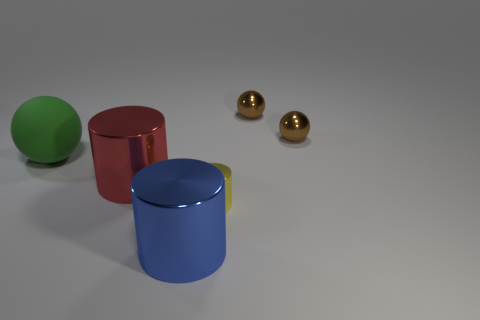What material is the sphere to the left of the big shiny thing that is in front of the metallic cylinder that is on the right side of the big blue metal object?
Your response must be concise. Rubber. Does the small metallic cylinder have the same color as the shiny cylinder that is left of the big blue metal cylinder?
Provide a succinct answer. No. How many things are either things right of the large matte sphere or things that are in front of the small yellow cylinder?
Offer a terse response. 5. What is the shape of the big shiny object in front of the tiny thing in front of the large ball?
Offer a terse response. Cylinder. Is there a blue cylinder that has the same material as the red object?
Offer a very short reply. Yes. There is another big thing that is the same shape as the blue object; what is its color?
Keep it short and to the point. Red. Is the number of tiny metallic balls that are on the left side of the large green matte sphere less than the number of big cylinders that are on the right side of the big blue cylinder?
Make the answer very short. No. How many other objects are there of the same shape as the large red object?
Provide a succinct answer. 2. Is the number of big shiny objects to the right of the yellow cylinder less than the number of big green rubber things?
Provide a short and direct response. Yes. What is the material of the tiny thing that is in front of the green sphere?
Provide a short and direct response. Metal. 